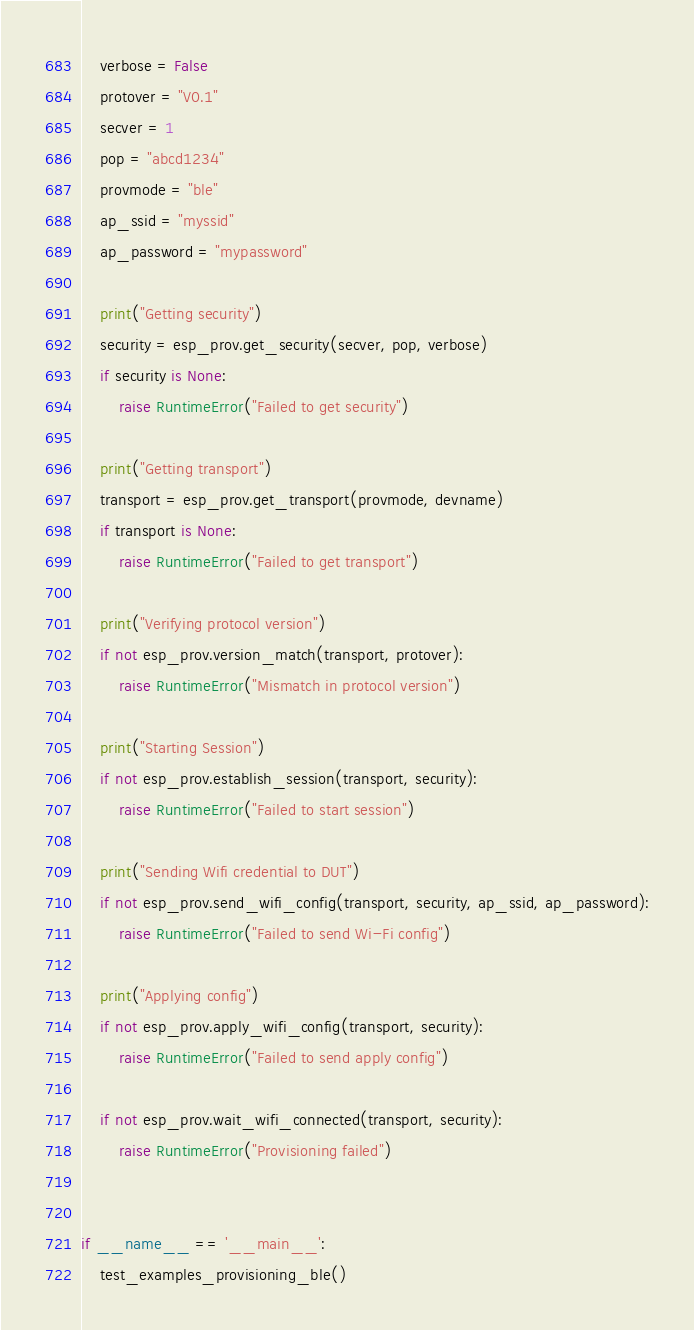Convert code to text. <code><loc_0><loc_0><loc_500><loc_500><_Python_>    verbose = False
    protover = "V0.1"
    secver = 1
    pop = "abcd1234"
    provmode = "ble"
    ap_ssid = "myssid"
    ap_password = "mypassword"

    print("Getting security")
    security = esp_prov.get_security(secver, pop, verbose)
    if security is None:
        raise RuntimeError("Failed to get security")

    print("Getting transport")
    transport = esp_prov.get_transport(provmode, devname)
    if transport is None:
        raise RuntimeError("Failed to get transport")

    print("Verifying protocol version")
    if not esp_prov.version_match(transport, protover):
        raise RuntimeError("Mismatch in protocol version")

    print("Starting Session")
    if not esp_prov.establish_session(transport, security):
        raise RuntimeError("Failed to start session")

    print("Sending Wifi credential to DUT")
    if not esp_prov.send_wifi_config(transport, security, ap_ssid, ap_password):
        raise RuntimeError("Failed to send Wi-Fi config")

    print("Applying config")
    if not esp_prov.apply_wifi_config(transport, security):
        raise RuntimeError("Failed to send apply config")

    if not esp_prov.wait_wifi_connected(transport, security):
        raise RuntimeError("Provisioning failed")


if __name__ == '__main__':
    test_examples_provisioning_ble()
</code> 